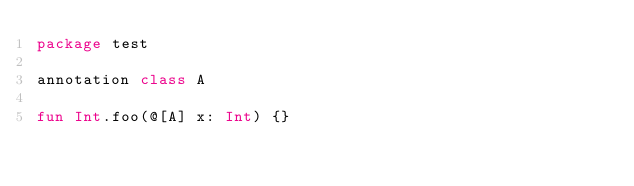Convert code to text. <code><loc_0><loc_0><loc_500><loc_500><_Kotlin_>package test

annotation class A

fun Int.foo(@[A] x: Int) {}
</code> 